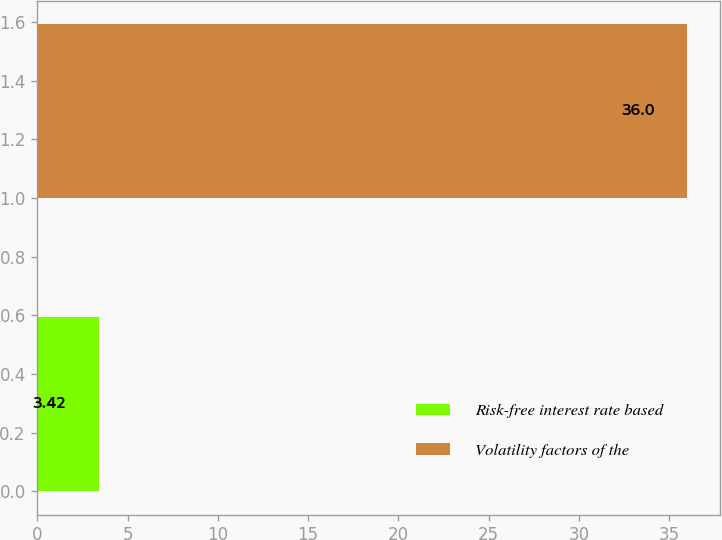Convert chart. <chart><loc_0><loc_0><loc_500><loc_500><bar_chart><fcel>Risk-free interest rate based<fcel>Volatility factors of the<nl><fcel>3.42<fcel>36<nl></chart> 